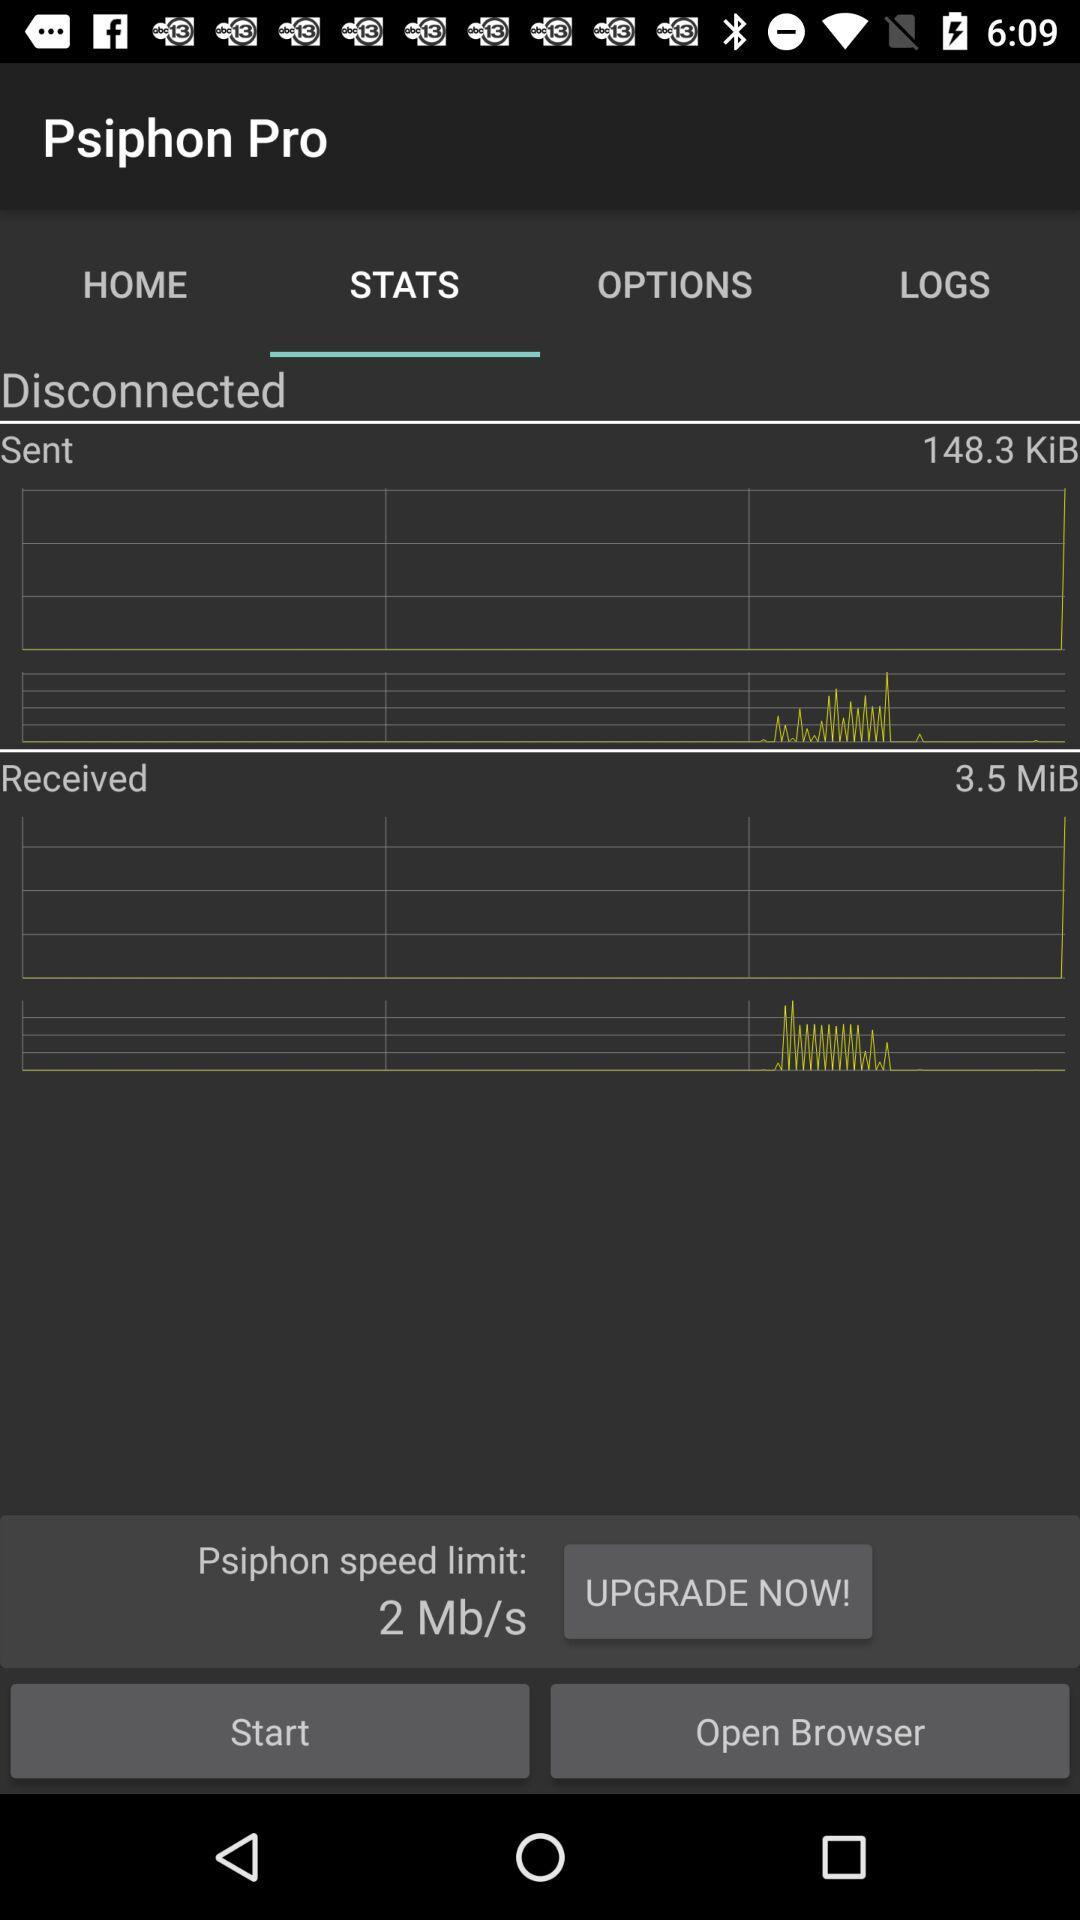What is the speed limit of Psiphon?
Answer the question using a single word or phrase. 2 Mb/s 